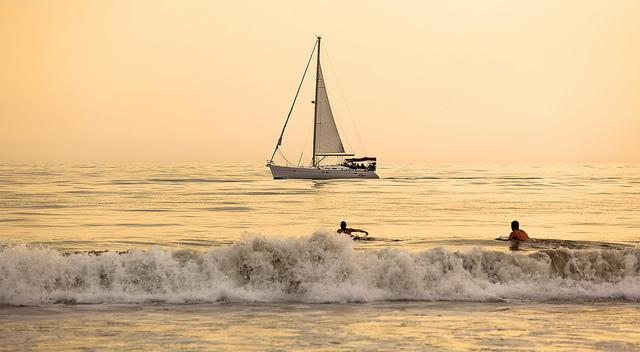How is this boat powered? Please explain your reasoning. wind. The boat has a sail and is in the water. 